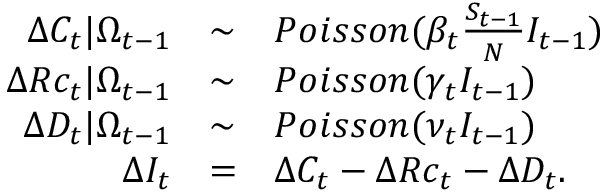Convert formula to latex. <formula><loc_0><loc_0><loc_500><loc_500>\begin{array} { r c l } { \Delta C _ { t } | \Omega _ { t - 1 } } & { \sim } & { P o i s s o n ( \beta _ { t } \frac { S _ { t - 1 } } { N } I _ { t - 1 } ) } \\ { \Delta R c _ { t } | \Omega _ { t - 1 } } & { \sim } & { P o i s s o n ( \gamma _ { t } I _ { t - 1 } ) } \\ { \Delta D _ { t } | \Omega _ { t - 1 } } & { \sim } & { P o i s s o n ( \nu _ { t } I _ { t - 1 } ) } \\ { \Delta I _ { t } } & { = } & { \Delta C _ { t } - \Delta R c _ { t } - \Delta D _ { t } . } \end{array}</formula> 